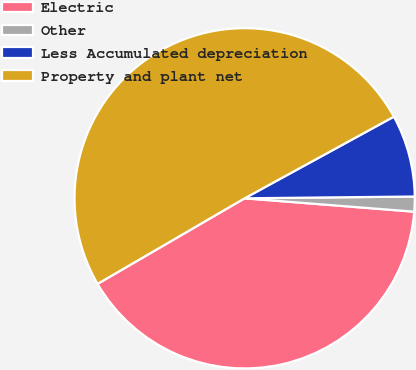<chart> <loc_0><loc_0><loc_500><loc_500><pie_chart><fcel>Electric<fcel>Other<fcel>Less Accumulated depreciation<fcel>Property and plant net<nl><fcel>40.36%<fcel>1.42%<fcel>7.8%<fcel>50.42%<nl></chart> 